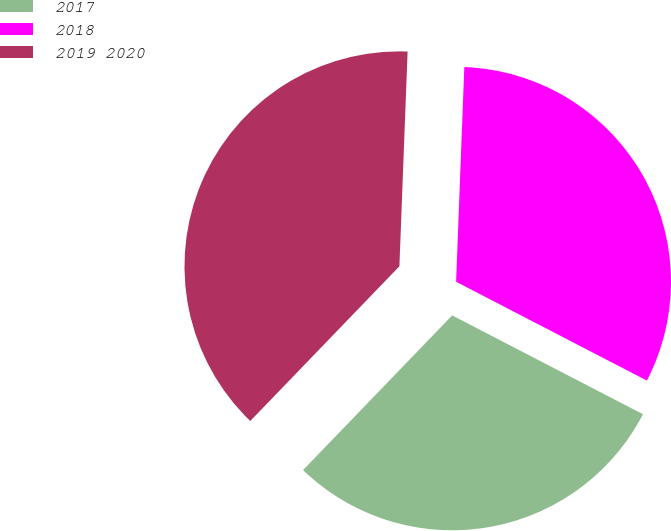Convert chart to OTSL. <chart><loc_0><loc_0><loc_500><loc_500><pie_chart><fcel>2017<fcel>2018<fcel>2019 2020<nl><fcel>29.6%<fcel>32.0%<fcel>38.4%<nl></chart> 